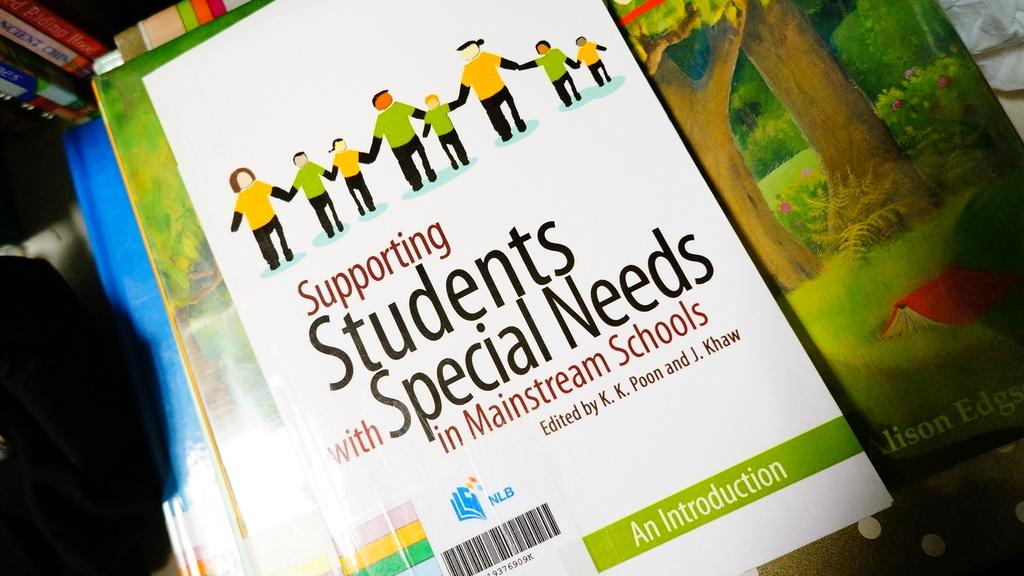<image>
Give a short and clear explanation of the subsequent image. A book about supporting Students with Special needs in mainstream schools. 